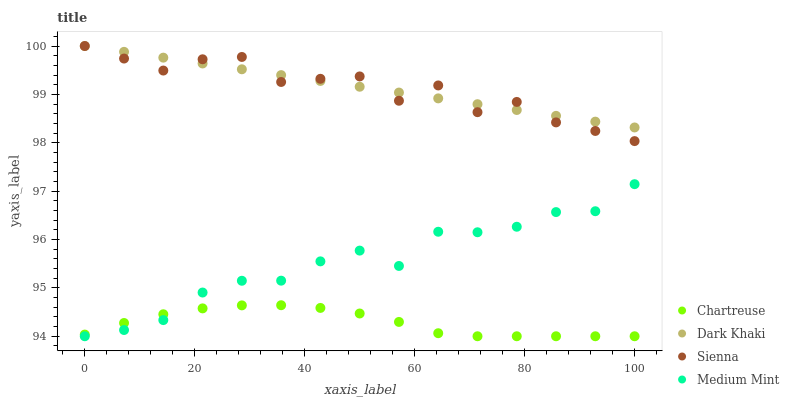Does Chartreuse have the minimum area under the curve?
Answer yes or no. Yes. Does Dark Khaki have the maximum area under the curve?
Answer yes or no. Yes. Does Sienna have the minimum area under the curve?
Answer yes or no. No. Does Sienna have the maximum area under the curve?
Answer yes or no. No. Is Dark Khaki the smoothest?
Answer yes or no. Yes. Is Sienna the roughest?
Answer yes or no. Yes. Is Chartreuse the smoothest?
Answer yes or no. No. Is Chartreuse the roughest?
Answer yes or no. No. Does Chartreuse have the lowest value?
Answer yes or no. Yes. Does Sienna have the lowest value?
Answer yes or no. No. Does Sienna have the highest value?
Answer yes or no. Yes. Does Chartreuse have the highest value?
Answer yes or no. No. Is Medium Mint less than Sienna?
Answer yes or no. Yes. Is Sienna greater than Chartreuse?
Answer yes or no. Yes. Does Medium Mint intersect Chartreuse?
Answer yes or no. Yes. Is Medium Mint less than Chartreuse?
Answer yes or no. No. Is Medium Mint greater than Chartreuse?
Answer yes or no. No. Does Medium Mint intersect Sienna?
Answer yes or no. No. 